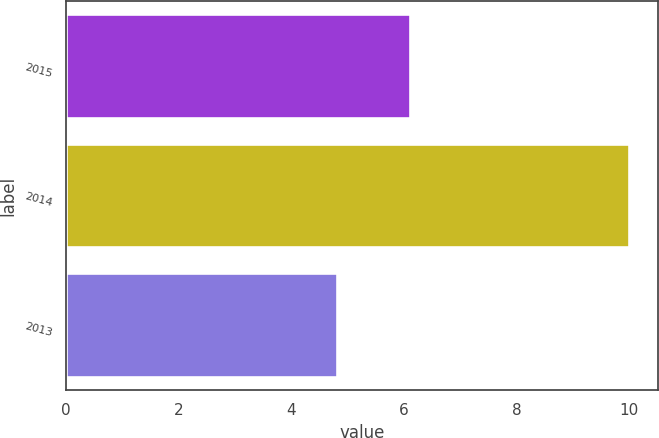<chart> <loc_0><loc_0><loc_500><loc_500><bar_chart><fcel>2015<fcel>2014<fcel>2013<nl><fcel>6.1<fcel>10<fcel>4.8<nl></chart> 